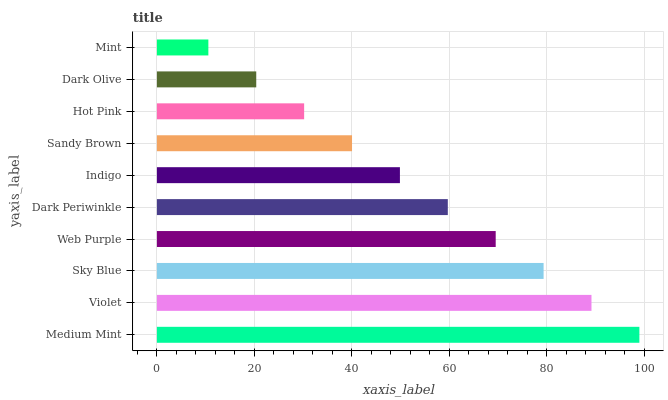Is Mint the minimum?
Answer yes or no. Yes. Is Medium Mint the maximum?
Answer yes or no. Yes. Is Violet the minimum?
Answer yes or no. No. Is Violet the maximum?
Answer yes or no. No. Is Medium Mint greater than Violet?
Answer yes or no. Yes. Is Violet less than Medium Mint?
Answer yes or no. Yes. Is Violet greater than Medium Mint?
Answer yes or no. No. Is Medium Mint less than Violet?
Answer yes or no. No. Is Dark Periwinkle the high median?
Answer yes or no. Yes. Is Indigo the low median?
Answer yes or no. Yes. Is Sandy Brown the high median?
Answer yes or no. No. Is Dark Olive the low median?
Answer yes or no. No. 